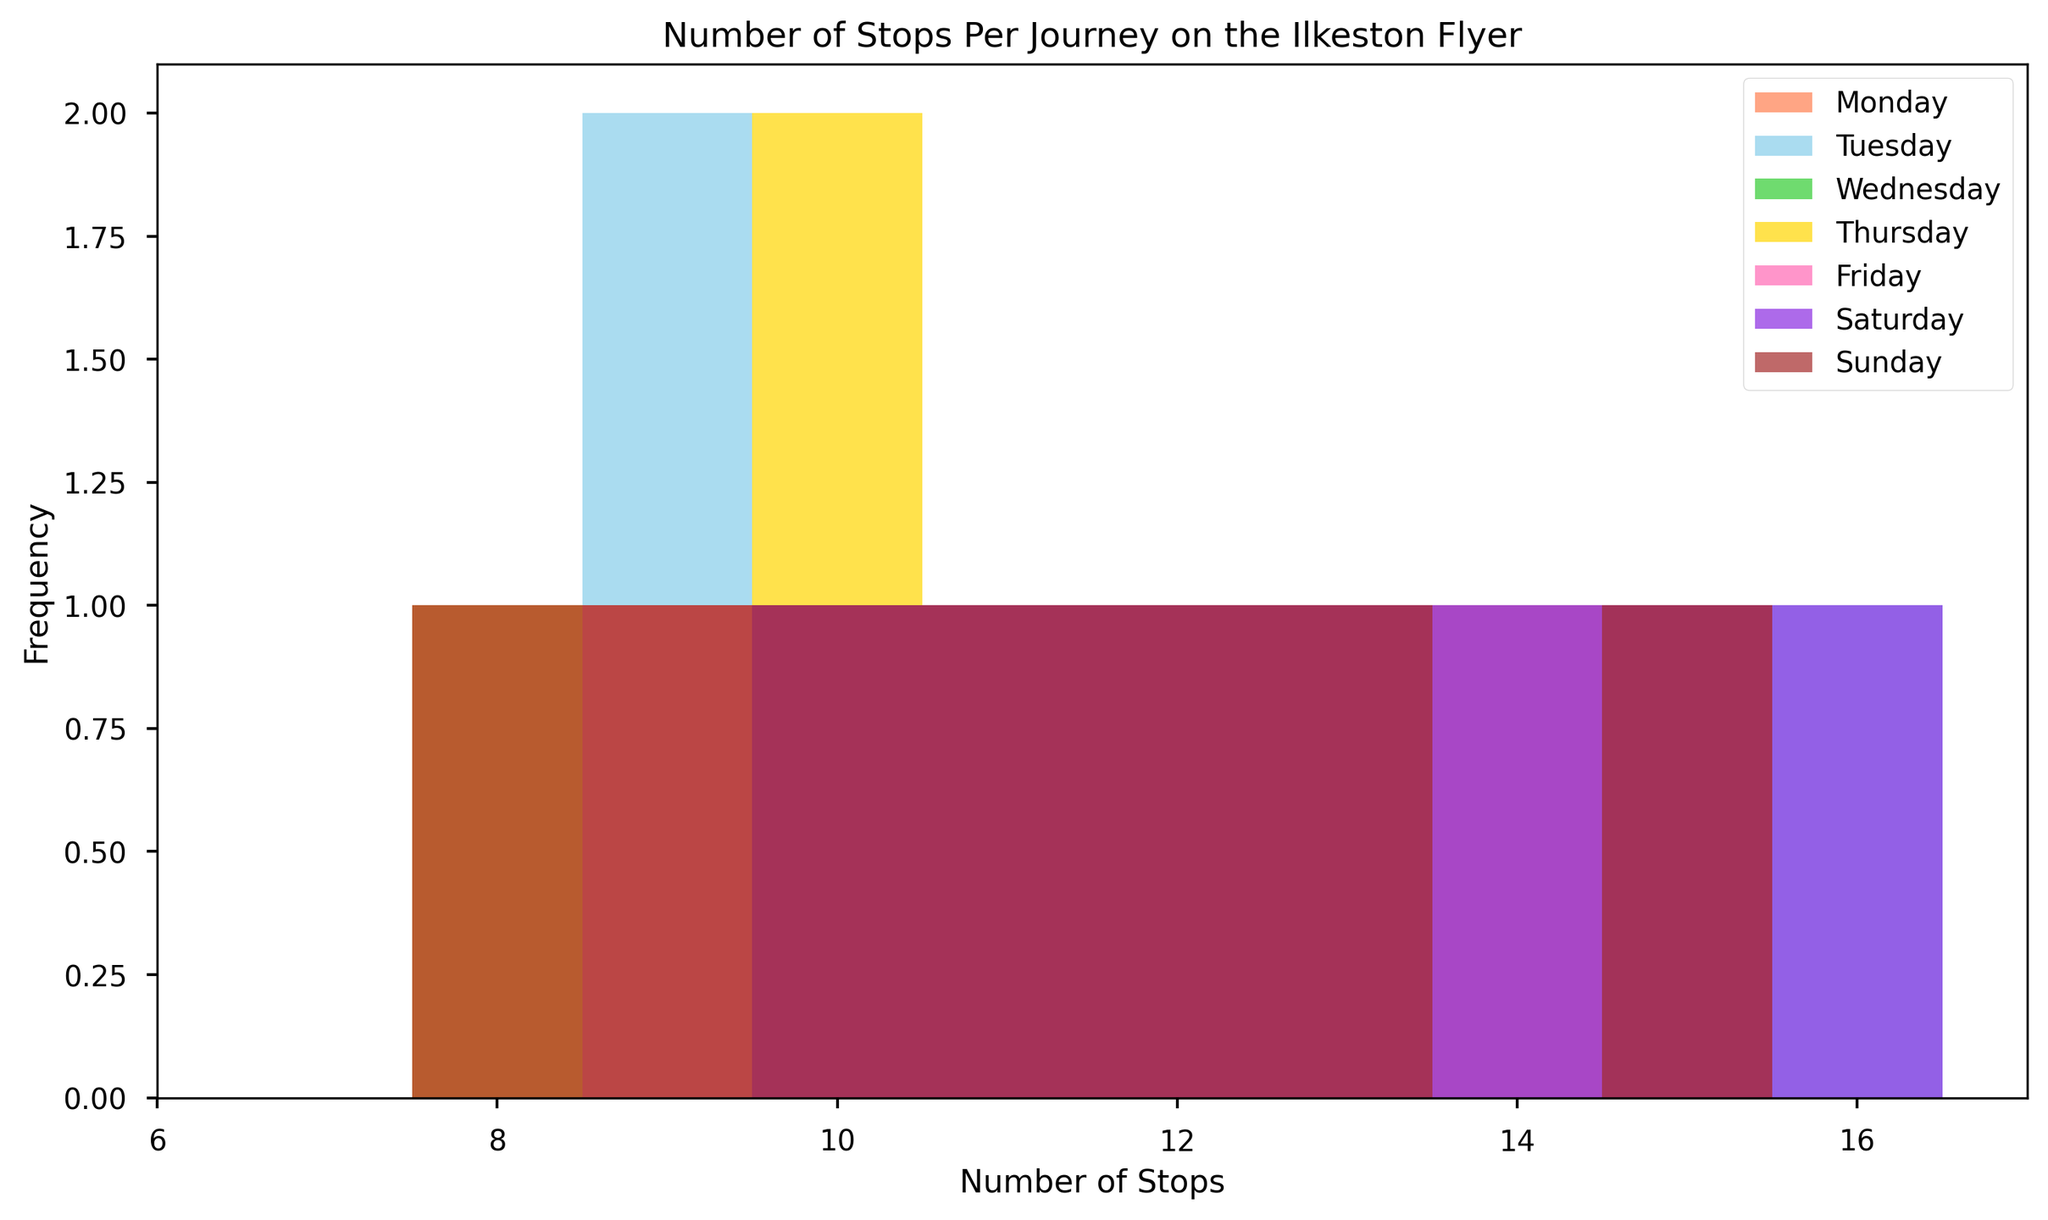Which day has the highest frequency of journeys with 15 stops? Look at the height of the bars corresponding to 15 stops. The tallest bar at 15 stops is for Saturday.
Answer: Saturday On which day(s) do we see journeys with 8 stops? Identify the days that have bars at the 8 stops slot. Bars are present at 8 stops for Monday, Tuesday, Thursday, and Sunday.
Answer: Monday, Tuesday, Thursday, Sunday Comparing Monday and Saturday, which day has a more diverse range of stops? Look at the range of bars for Monday and Saturday. Saturday has bars from 10 to 16 stops whereas Monday has bars from 8 to 15 stops.
Answer: Saturday What is the most common number of stops on Fridays? Determine the tallest bar for Friday. The tallest bars for Friday are at 9, 10, 11, 12, 13, 15—each with the same height.
Answer: 9, 10, 11, 12, 13, 15 How many more stops are most frequent on Wednesday compared to Sunday? Compare the tallest bars on Wednesday and Sunday; Wednesday’s tallest bar is at 14 stops, Sunday’s tallest bar is at 10, 12, and 13 stops (equal heights).
Answer: +1 stop on Wednesday Which day has the least diversity in the number of stops? Identify the day with the least range of bar heights. Tuesday has the stops from 8 to 16 stops, but the range is not as varied or frequent as the others.
Answer: Tuesday What’s the average range of stops per journey across all days? Compute the average of the range (max-min stops) for each day. Example: [(15-8), (16-9), (15-9), (14-8), (15-9), (16-10), (15-8)] and then calculate the average of these values.
Answer: 7.43 stops How does the frequency of journeys with 12 stops on Wednesday compare to Thursday? Observe the height of bars at 12 stops for Wednesday and Thursday. Both days have bars of similar heights at 12 stops.
Answer: Equal On which day do journeys frequently have 16 stops? Look for the presence and height of bars at 16 stops. Saturday and Tuesday both have high frequencies at 16 stops.
Answer: Saturday, Tuesday 